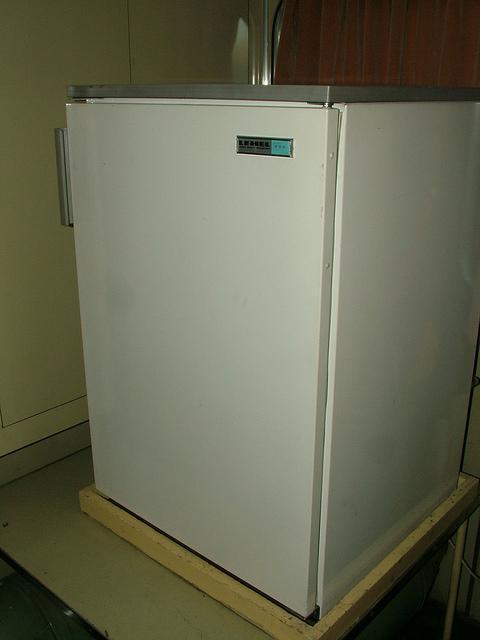How many doors are on this appliance?
Give a very brief answer. 1. How many doors is on this object?
Give a very brief answer. 1. How many refrigerators are in the photo?
Give a very brief answer. 2. How many sheep are standing in picture?
Give a very brief answer. 0. 